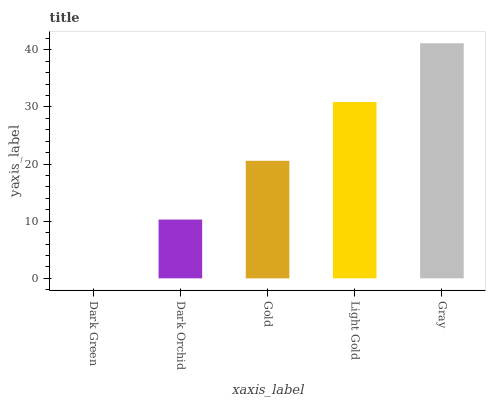Is Dark Orchid the minimum?
Answer yes or no. No. Is Dark Orchid the maximum?
Answer yes or no. No. Is Dark Orchid greater than Dark Green?
Answer yes or no. Yes. Is Dark Green less than Dark Orchid?
Answer yes or no. Yes. Is Dark Green greater than Dark Orchid?
Answer yes or no. No. Is Dark Orchid less than Dark Green?
Answer yes or no. No. Is Gold the high median?
Answer yes or no. Yes. Is Gold the low median?
Answer yes or no. Yes. Is Light Gold the high median?
Answer yes or no. No. Is Dark Orchid the low median?
Answer yes or no. No. 